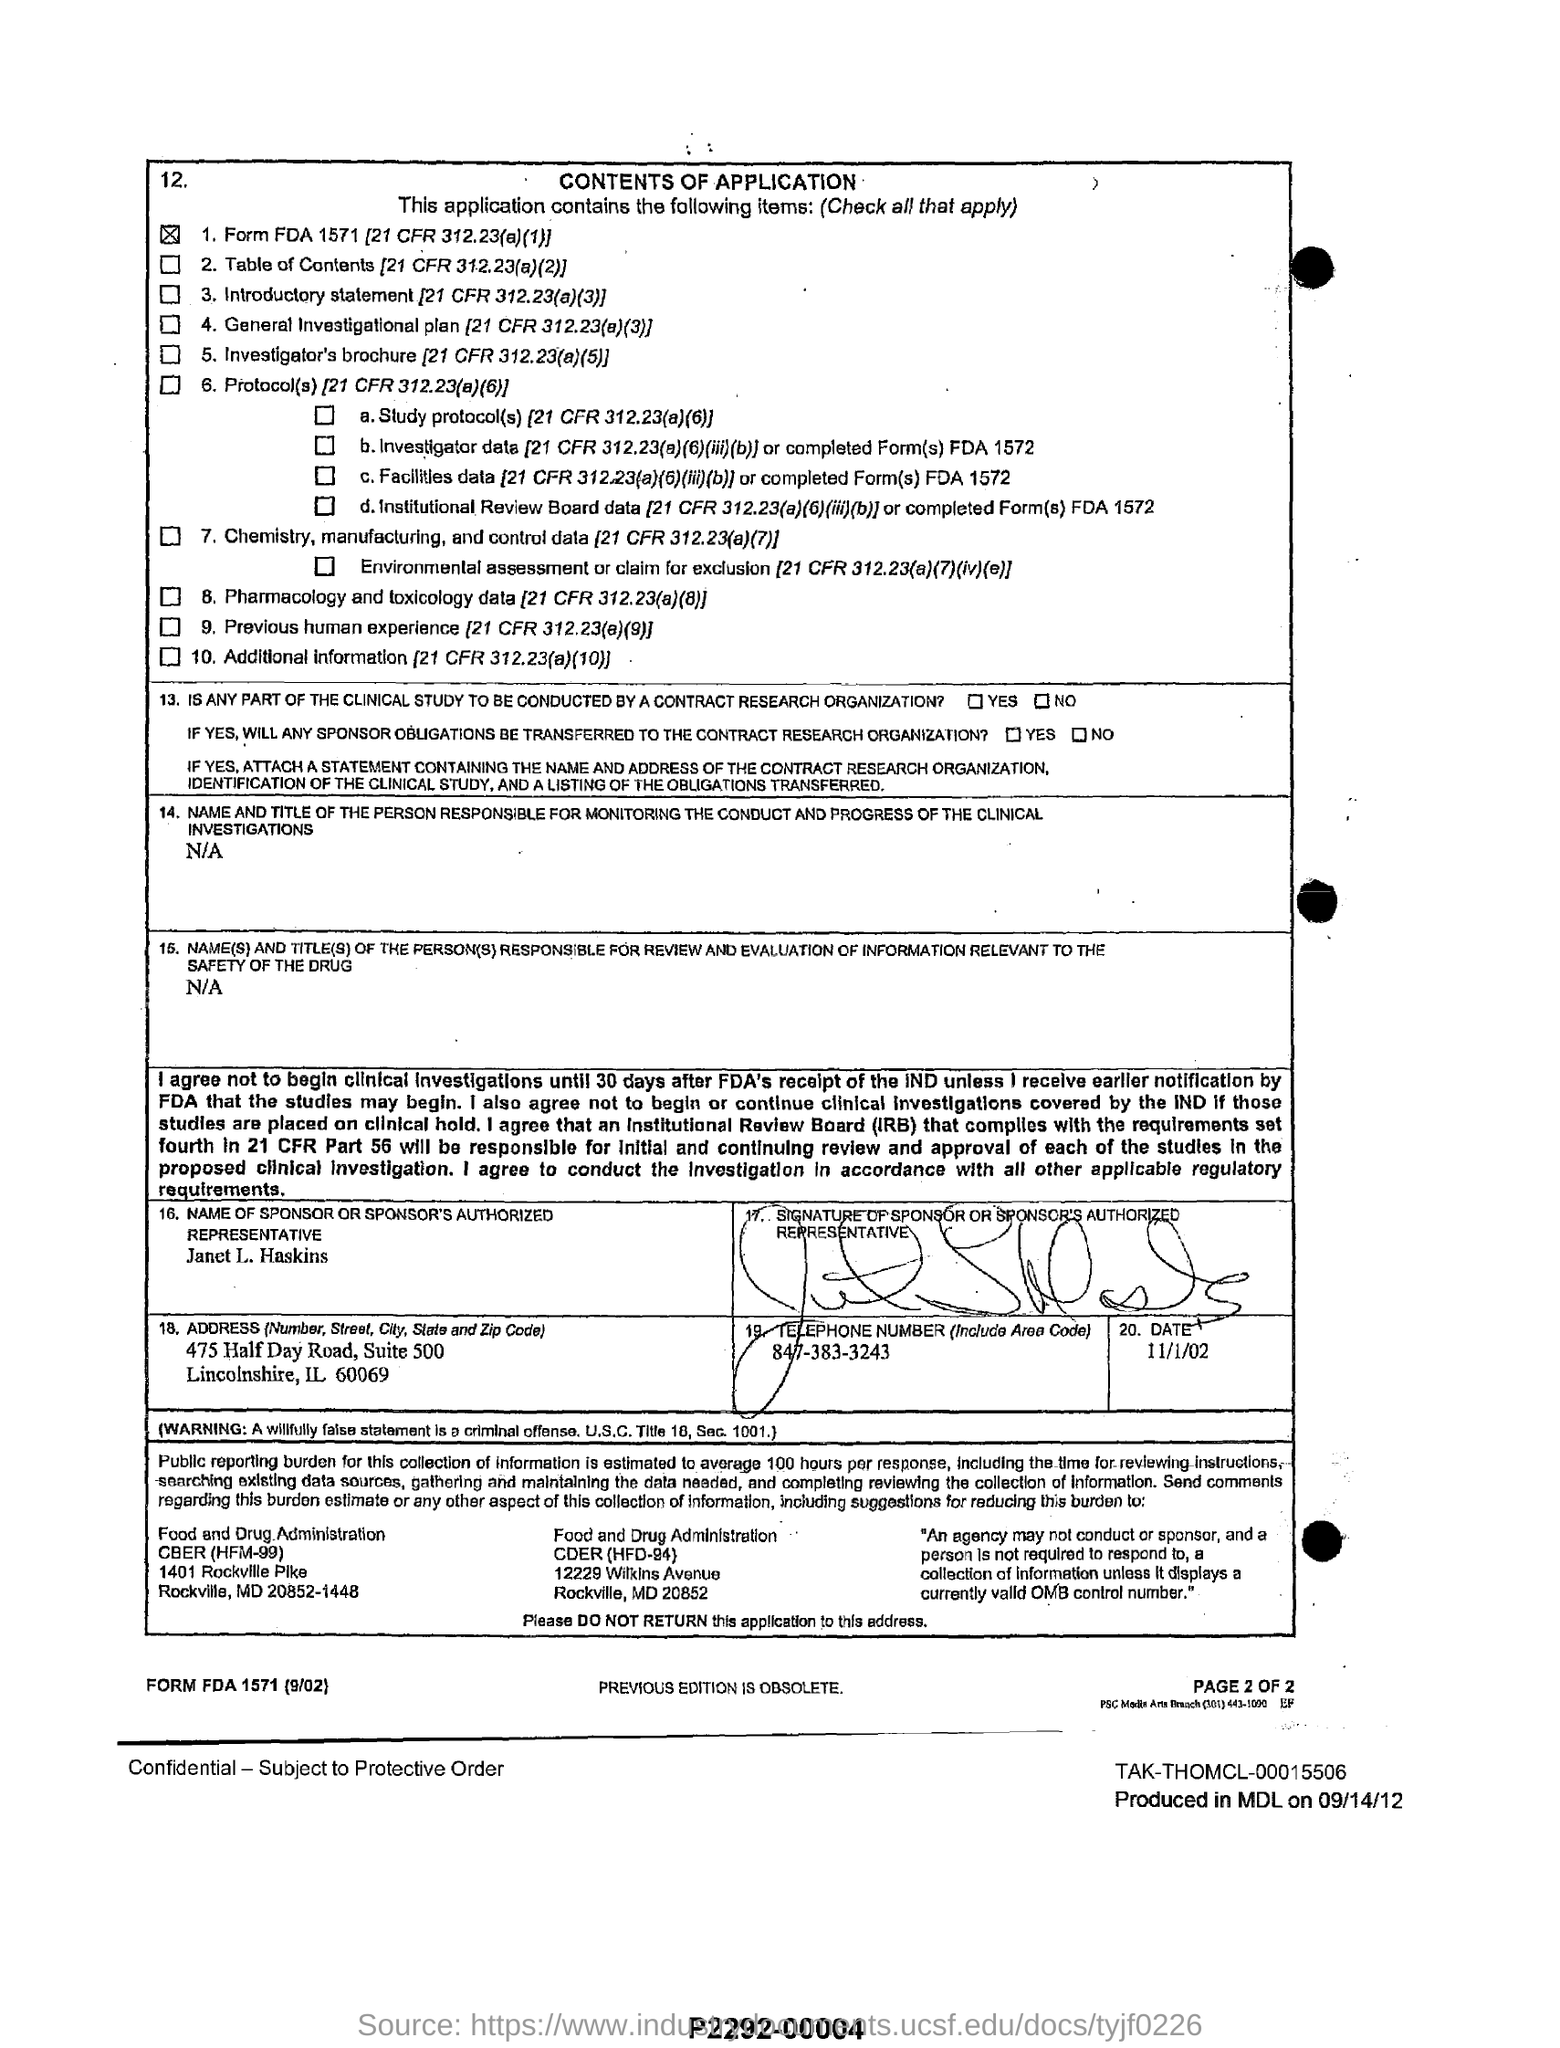List a handful of essential elements in this visual. The name of the sponsor or the sponsor's authorized representative given in the application is Janet L. Haskins. The telephone number of Janet L. Haskins is 847-383-3243. 